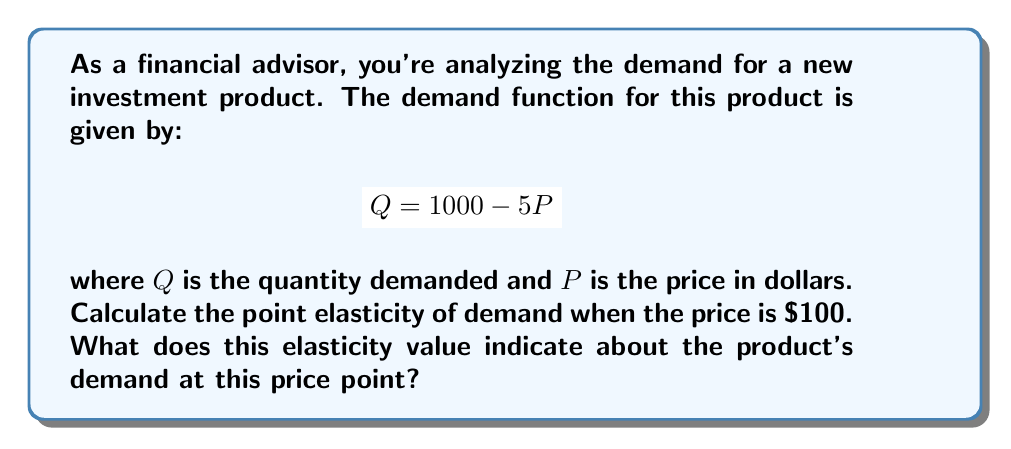Provide a solution to this math problem. To find the point elasticity of demand, we'll use the formula:

$$E_d = \left|\frac{dQ}{dP} \cdot \frac{P}{Q}\right|$$

Step 1: Find $\frac{dQ}{dP}$
From the demand function $Q = 1000 - 5P$, we can see that $\frac{dQ}{dP} = -5$

Step 2: Calculate $Q$ when $P = 100$
$Q = 1000 - 5(100) = 500$

Step 3: Substitute values into the elasticity formula
$$E_d = \left|-5 \cdot \frac{100}{500}\right| = \left|-5 \cdot \frac{1}{5}\right| = 1$$

Step 4: Interpret the result
An elasticity of 1 indicates unit elastic demand. This means that a 1% change in price will result in a 1% change in quantity demanded in the opposite direction.

For financial advisors, this information is crucial. It suggests that at a price of $100, the investment product is at a critical point where changes in price will proportionally affect demand. This can inform pricing strategies and help predict how changes in price might impact revenue.
Answer: $E_d = 1$ (unit elastic) 